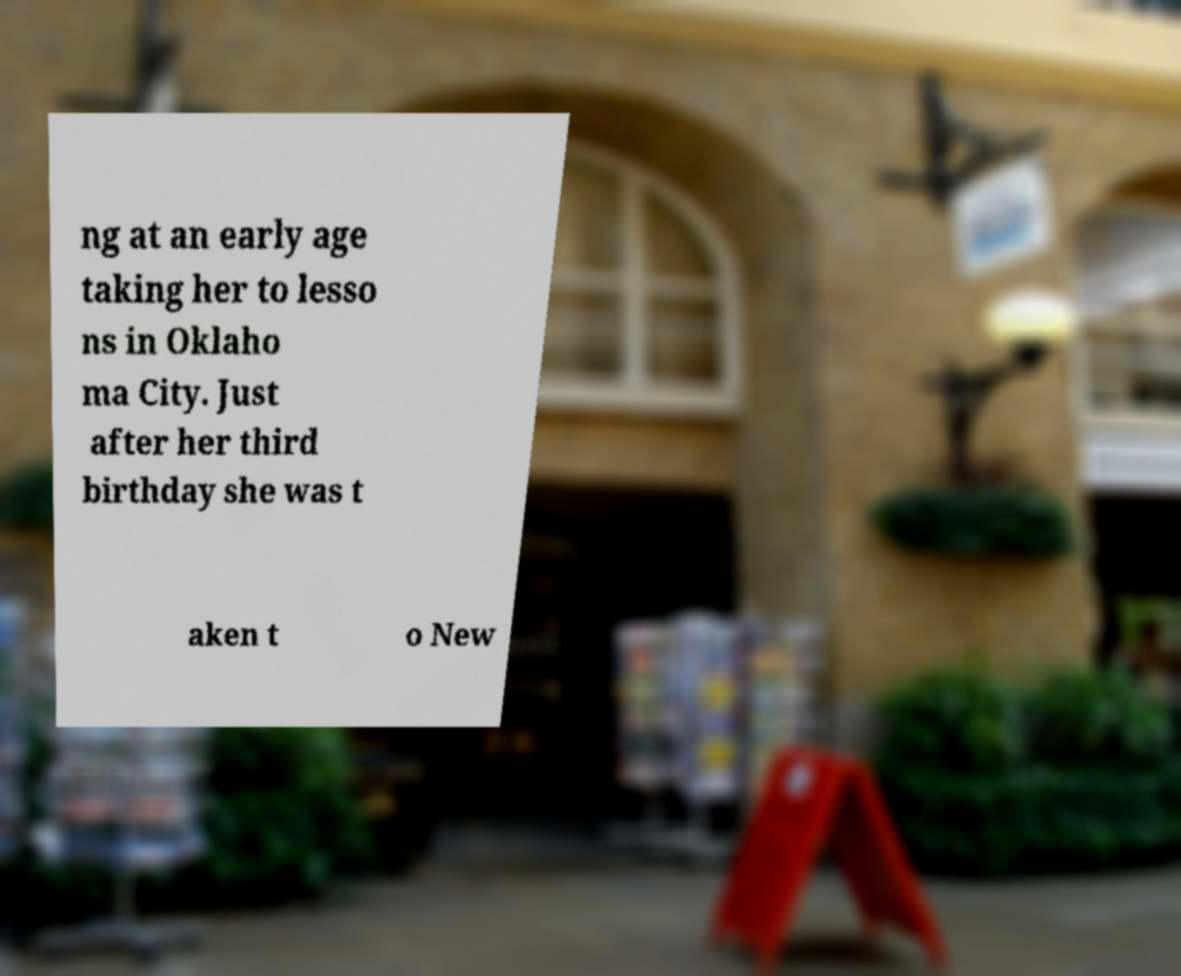Can you read and provide the text displayed in the image?This photo seems to have some interesting text. Can you extract and type it out for me? ng at an early age taking her to lesso ns in Oklaho ma City. Just after her third birthday she was t aken t o New 